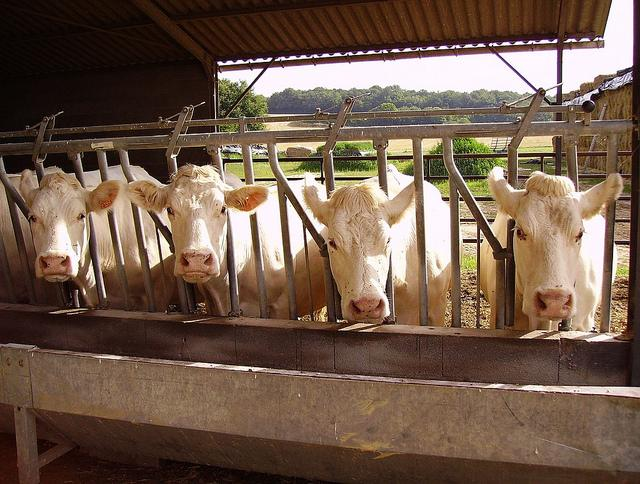Why are these cows held in place at the feeder?

Choices:
A) butcher
B) milk
C) petting
D) helping milk 